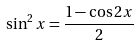<formula> <loc_0><loc_0><loc_500><loc_500>\sin ^ { 2 } x = \frac { 1 - \cos 2 x } { 2 }</formula> 